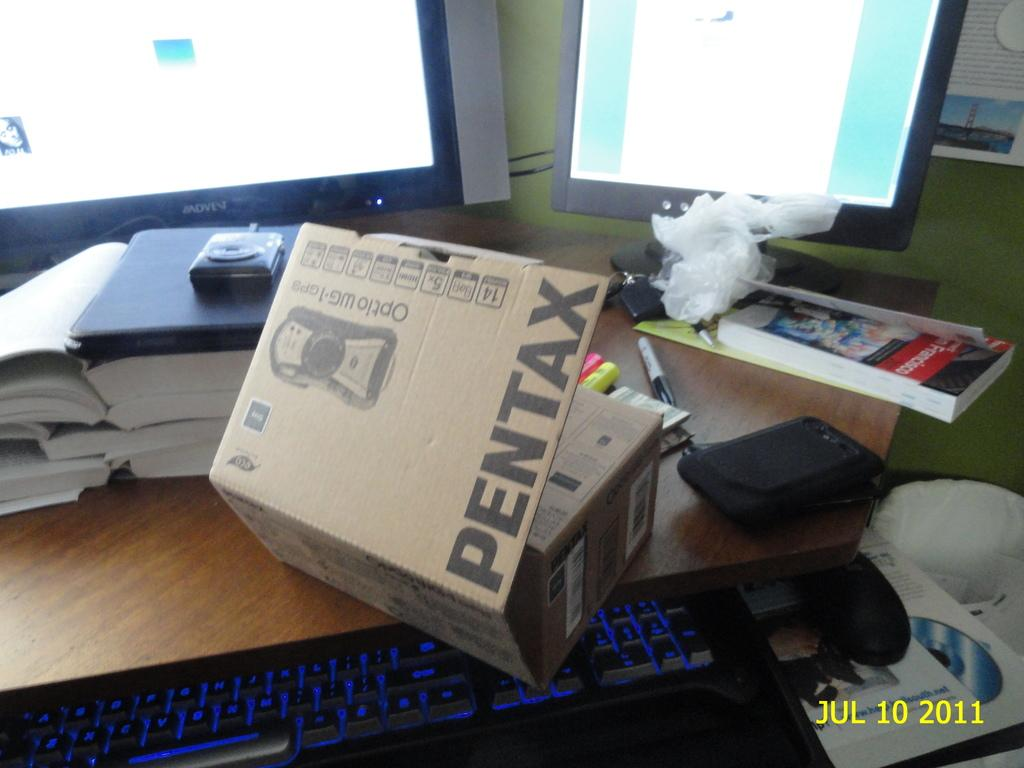Provide a one-sentence caption for the provided image. A Pentax box is partially opened on a table. 